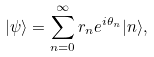<formula> <loc_0><loc_0><loc_500><loc_500>| \psi \rangle = \sum _ { n = 0 } ^ { \infty } r _ { n } e ^ { i \theta _ { n } } | n \rangle ,</formula> 